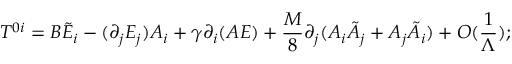<formula> <loc_0><loc_0><loc_500><loc_500>T ^ { 0 i } = B \tilde { E } _ { i } - ( \partial _ { j } E _ { j } ) A _ { i } + \gamma \partial _ { i } ( A E ) + \frac { M } { 8 } \partial _ { j } ( A _ { i } \tilde { A } _ { j } + A _ { j } \tilde { A } _ { i } ) + O ( \frac { 1 } { \Lambda } ) ;</formula> 